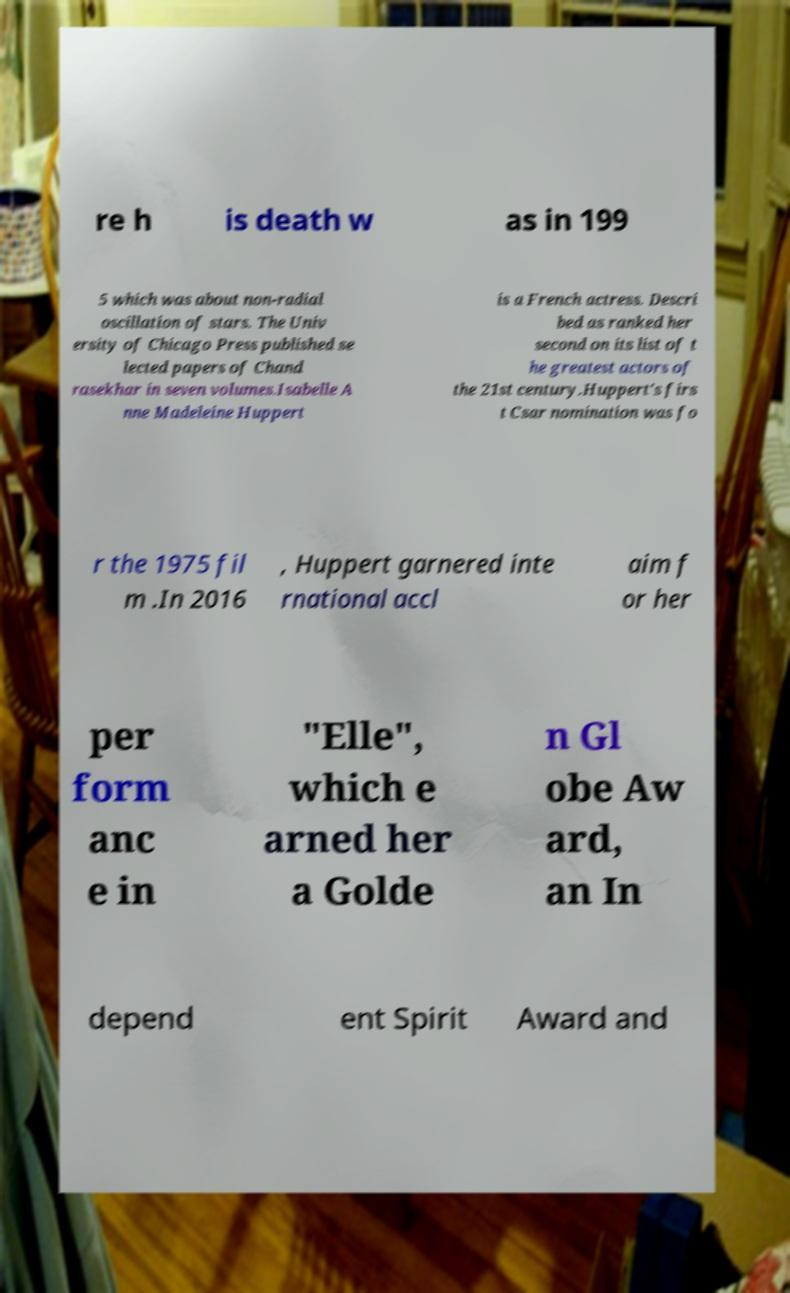Can you accurately transcribe the text from the provided image for me? re h is death w as in 199 5 which was about non-radial oscillation of stars. The Univ ersity of Chicago Press published se lected papers of Chand rasekhar in seven volumes.Isabelle A nne Madeleine Huppert is a French actress. Descri bed as ranked her second on its list of t he greatest actors of the 21st century.Huppert's firs t Csar nomination was fo r the 1975 fil m .In 2016 , Huppert garnered inte rnational accl aim f or her per form anc e in "Elle", which e arned her a Golde n Gl obe Aw ard, an In depend ent Spirit Award and 